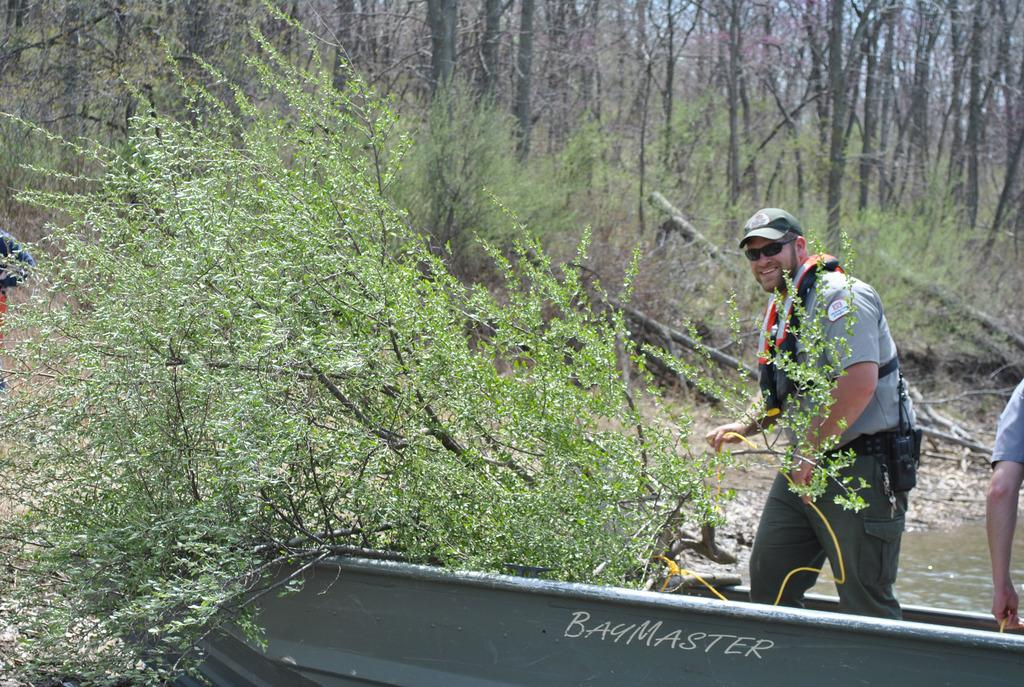Provide a one-sentence caption for the provided image. Two fisherman are riding a boat called BayMaster. 